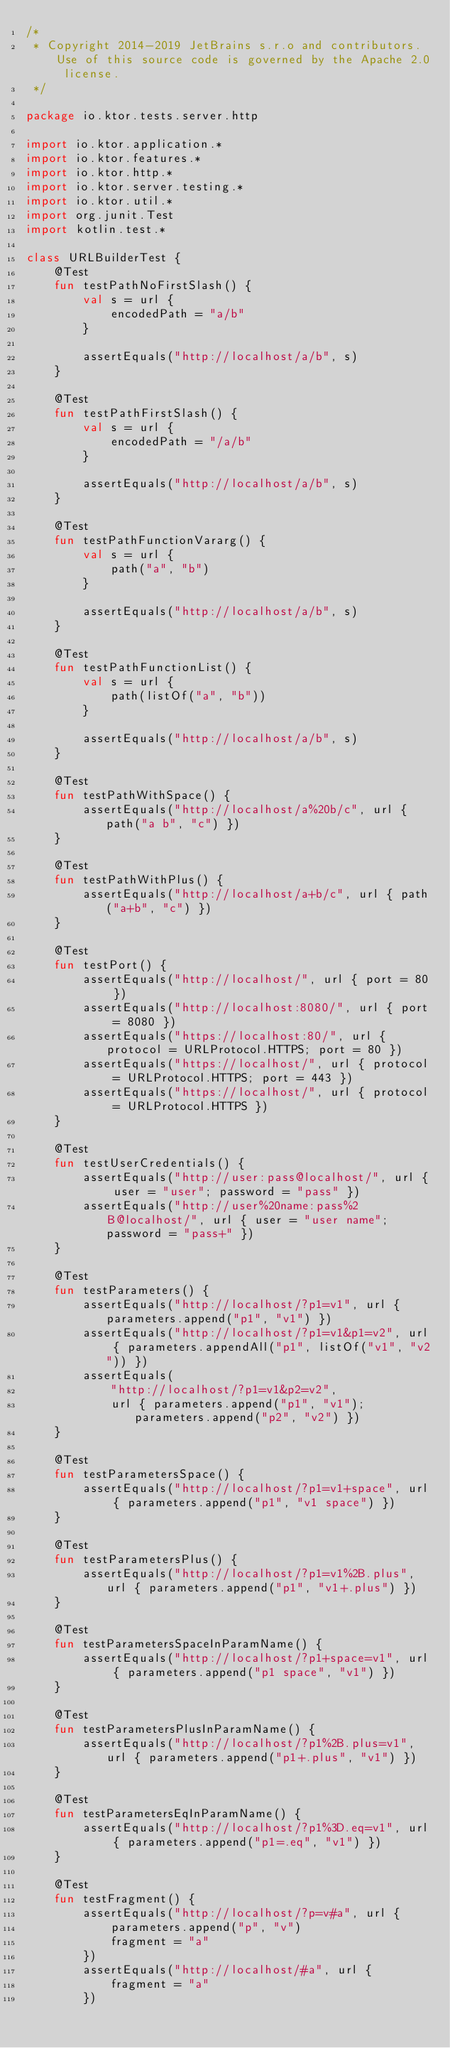<code> <loc_0><loc_0><loc_500><loc_500><_Kotlin_>/*
 * Copyright 2014-2019 JetBrains s.r.o and contributors. Use of this source code is governed by the Apache 2.0 license.
 */

package io.ktor.tests.server.http

import io.ktor.application.*
import io.ktor.features.*
import io.ktor.http.*
import io.ktor.server.testing.*
import io.ktor.util.*
import org.junit.Test
import kotlin.test.*

class URLBuilderTest {
    @Test
    fun testPathNoFirstSlash() {
        val s = url {
            encodedPath = "a/b"
        }

        assertEquals("http://localhost/a/b", s)
    }

    @Test
    fun testPathFirstSlash() {
        val s = url {
            encodedPath = "/a/b"
        }

        assertEquals("http://localhost/a/b", s)
    }

    @Test
    fun testPathFunctionVararg() {
        val s = url {
            path("a", "b")
        }

        assertEquals("http://localhost/a/b", s)
    }

    @Test
    fun testPathFunctionList() {
        val s = url {
            path(listOf("a", "b"))
        }

        assertEquals("http://localhost/a/b", s)
    }

    @Test
    fun testPathWithSpace() {
        assertEquals("http://localhost/a%20b/c", url { path("a b", "c") })
    }

    @Test
    fun testPathWithPlus() {
        assertEquals("http://localhost/a+b/c", url { path("a+b", "c") })
    }

    @Test
    fun testPort() {
        assertEquals("http://localhost/", url { port = 80 })
        assertEquals("http://localhost:8080/", url { port = 8080 })
        assertEquals("https://localhost:80/", url { protocol = URLProtocol.HTTPS; port = 80 })
        assertEquals("https://localhost/", url { protocol = URLProtocol.HTTPS; port = 443 })
        assertEquals("https://localhost/", url { protocol = URLProtocol.HTTPS })
    }

    @Test
    fun testUserCredentials() {
        assertEquals("http://user:pass@localhost/", url { user = "user"; password = "pass" })
        assertEquals("http://user%20name:pass%2B@localhost/", url { user = "user name"; password = "pass+" })
    }

    @Test
    fun testParameters() {
        assertEquals("http://localhost/?p1=v1", url { parameters.append("p1", "v1") })
        assertEquals("http://localhost/?p1=v1&p1=v2", url { parameters.appendAll("p1", listOf("v1", "v2")) })
        assertEquals(
            "http://localhost/?p1=v1&p2=v2",
            url { parameters.append("p1", "v1"); parameters.append("p2", "v2") })
    }

    @Test
    fun testParametersSpace() {
        assertEquals("http://localhost/?p1=v1+space", url { parameters.append("p1", "v1 space") })
    }

    @Test
    fun testParametersPlus() {
        assertEquals("http://localhost/?p1=v1%2B.plus", url { parameters.append("p1", "v1+.plus") })
    }

    @Test
    fun testParametersSpaceInParamName() {
        assertEquals("http://localhost/?p1+space=v1", url { parameters.append("p1 space", "v1") })
    }

    @Test
    fun testParametersPlusInParamName() {
        assertEquals("http://localhost/?p1%2B.plus=v1", url { parameters.append("p1+.plus", "v1") })
    }

    @Test
    fun testParametersEqInParamName() {
        assertEquals("http://localhost/?p1%3D.eq=v1", url { parameters.append("p1=.eq", "v1") })
    }

    @Test
    fun testFragment() {
        assertEquals("http://localhost/?p=v#a", url {
            parameters.append("p", "v")
            fragment = "a"
        })
        assertEquals("http://localhost/#a", url {
            fragment = "a"
        })</code> 